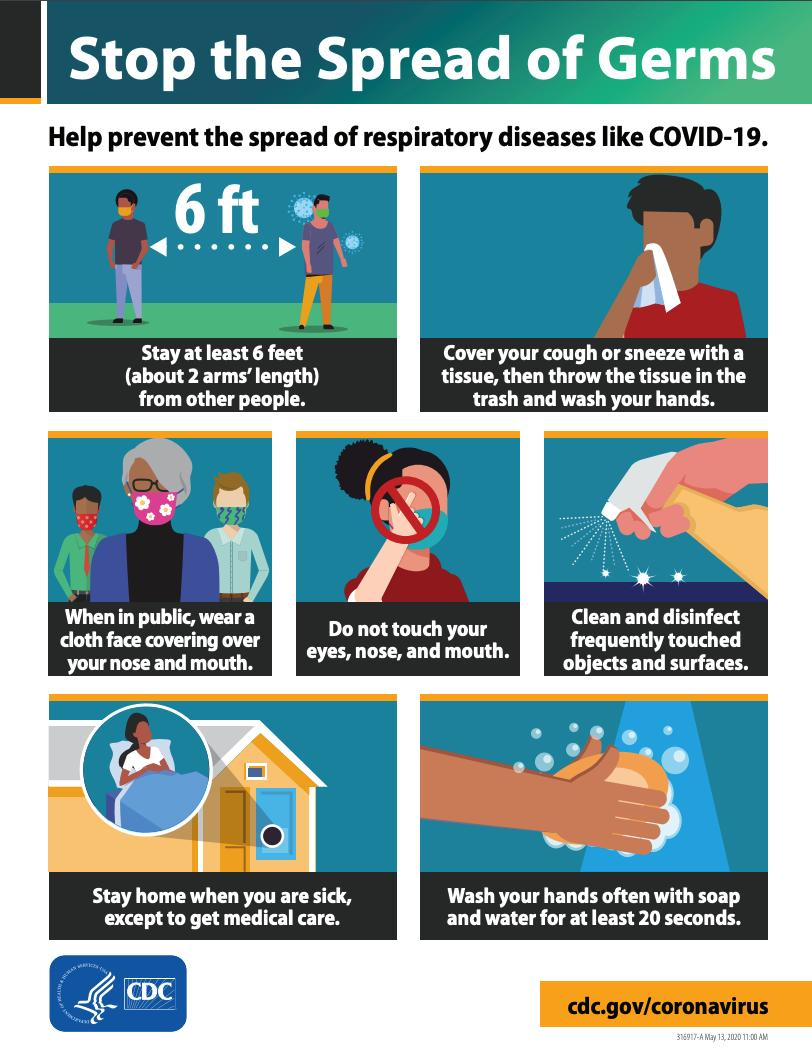Give some essential details in this illustration. This infographic image does not mention a specific number of items that are listed as 'don't'. There are six individuals depicted in the infographic image who are wearing masks. For the purpose of preventing the spread of COVID-19, it is recommended to wash one's hands for a minimum of 20 seconds. 